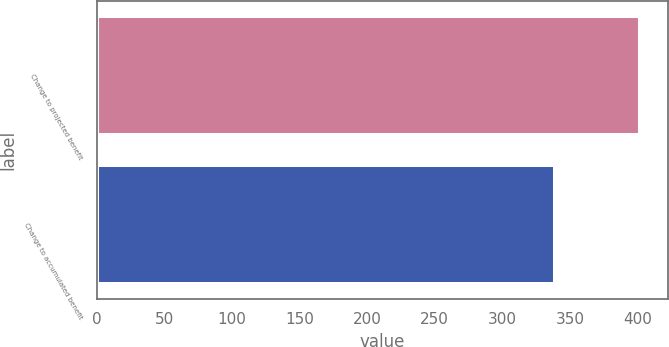Convert chart to OTSL. <chart><loc_0><loc_0><loc_500><loc_500><bar_chart><fcel>Change to projected benefit<fcel>Change to accumulated benefit<nl><fcel>402<fcel>339<nl></chart> 